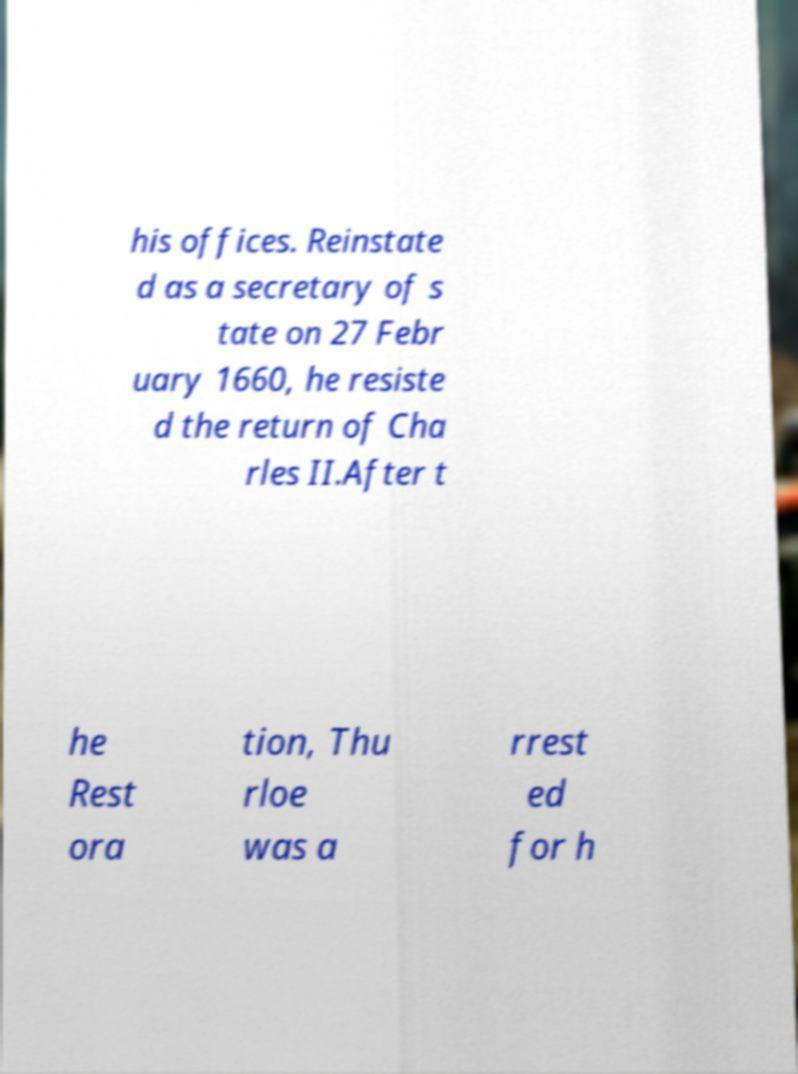Please identify and transcribe the text found in this image. his offices. Reinstate d as a secretary of s tate on 27 Febr uary 1660, he resiste d the return of Cha rles II.After t he Rest ora tion, Thu rloe was a rrest ed for h 